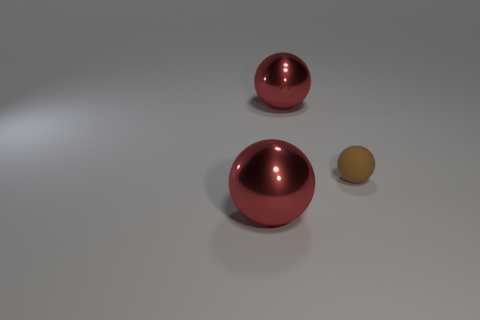Is there any other thing that has the same size as the brown matte object?
Your response must be concise. No. There is a thing in front of the brown sphere; what is its size?
Give a very brief answer. Large. Is there a yellow block made of the same material as the brown sphere?
Make the answer very short. No. Are there an equal number of brown objects that are left of the tiny thing and spheres?
Your response must be concise. No. Is there a large thing of the same color as the tiny rubber object?
Your response must be concise. No. There is a red shiny object that is in front of the large object that is behind the small brown thing; how big is it?
Your answer should be compact. Large. What number of brown objects have the same size as the brown rubber sphere?
Provide a succinct answer. 0. What number of metallic things are either large spheres or tiny spheres?
Provide a succinct answer. 2. There is a large red object behind the big red metallic sphere in front of the small brown sphere; what is it made of?
Keep it short and to the point. Metal. How many things are either small things or metal objects behind the tiny brown rubber ball?
Provide a short and direct response. 2. 